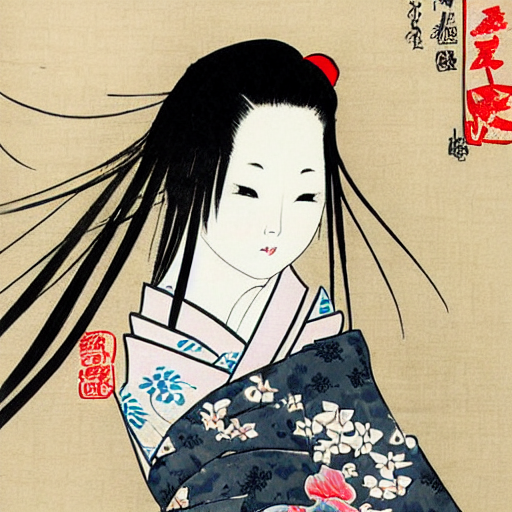How would you describe the composition of the image? The image features a Japanese ukiyo-e style woodblock print depicting a close-up portrait of an onnagata, or a male actor representing a woman in Kabuki theatre. The character is shown with a refined, pale complexion, accentuated with stark black hair, styled in a traditional Shimada hairstyle, often worn by young women or geisha. The facial features are delicately drawn, with a slight blush on the cheeks and small, pursed lips that are a hallmark of woodblock print design. The garment is adorned with a dark blue and floral pattern, and the overall composition gives prominence to the grace and poise of the figure, reflecting the aesthetic ideals and craftsmanship of the Edo period. 